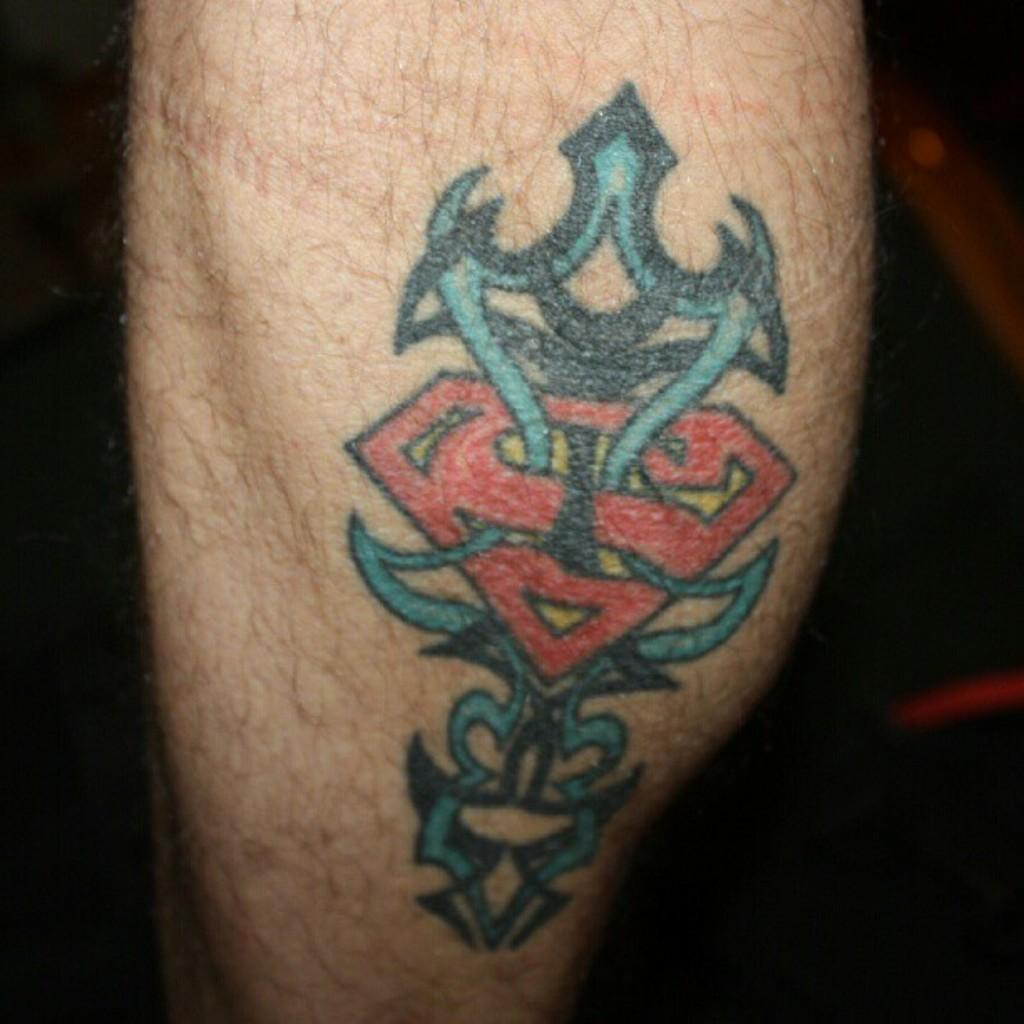What part of a person's body is visible in the image? There is a leg of a person in the image. Are there any distinguishing features on the leg? Yes, the leg has a tattoo. What can be observed about the background of the image? The background of the image is dark. What type of weather can be seen in the image? There is no weather visible in the image, as it only shows a leg with a tattoo and a dark background. 